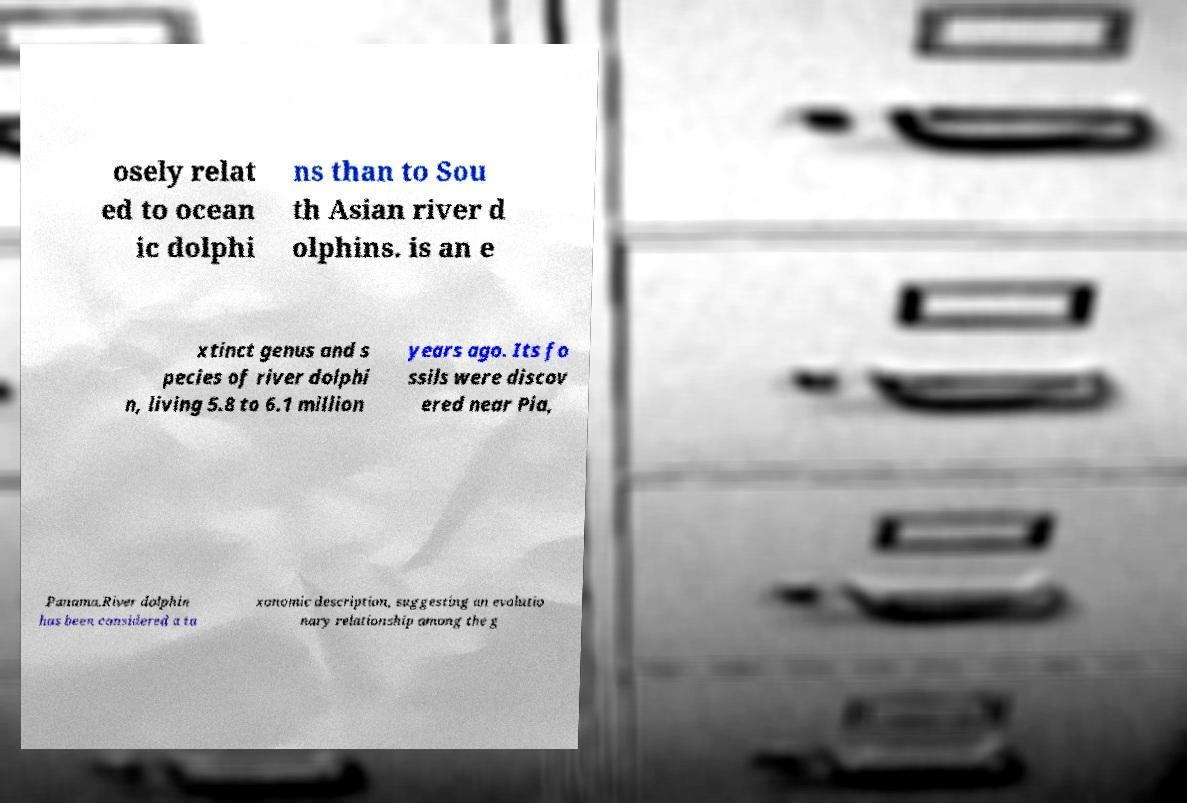Can you accurately transcribe the text from the provided image for me? osely relat ed to ocean ic dolphi ns than to Sou th Asian river d olphins. is an e xtinct genus and s pecies of river dolphi n, living 5.8 to 6.1 million years ago. Its fo ssils were discov ered near Pia, Panama.River dolphin has been considered a ta xonomic description, suggesting an evolutio nary relationship among the g 